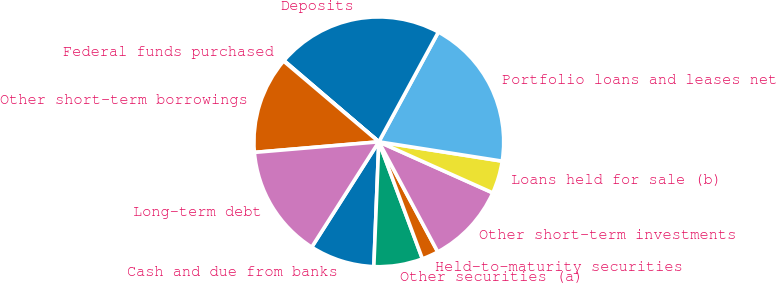<chart> <loc_0><loc_0><loc_500><loc_500><pie_chart><fcel>Cash and due from banks<fcel>Other securities (a)<fcel>Held-to-maturity securities<fcel>Other short-term investments<fcel>Loans held for sale (b)<fcel>Portfolio loans and leases net<fcel>Deposits<fcel>Federal funds purchased<fcel>Other short-term borrowings<fcel>Long-term debt<nl><fcel>8.39%<fcel>6.31%<fcel>2.15%<fcel>10.47%<fcel>4.23%<fcel>19.56%<fcel>21.64%<fcel>0.08%<fcel>12.54%<fcel>14.62%<nl></chart> 